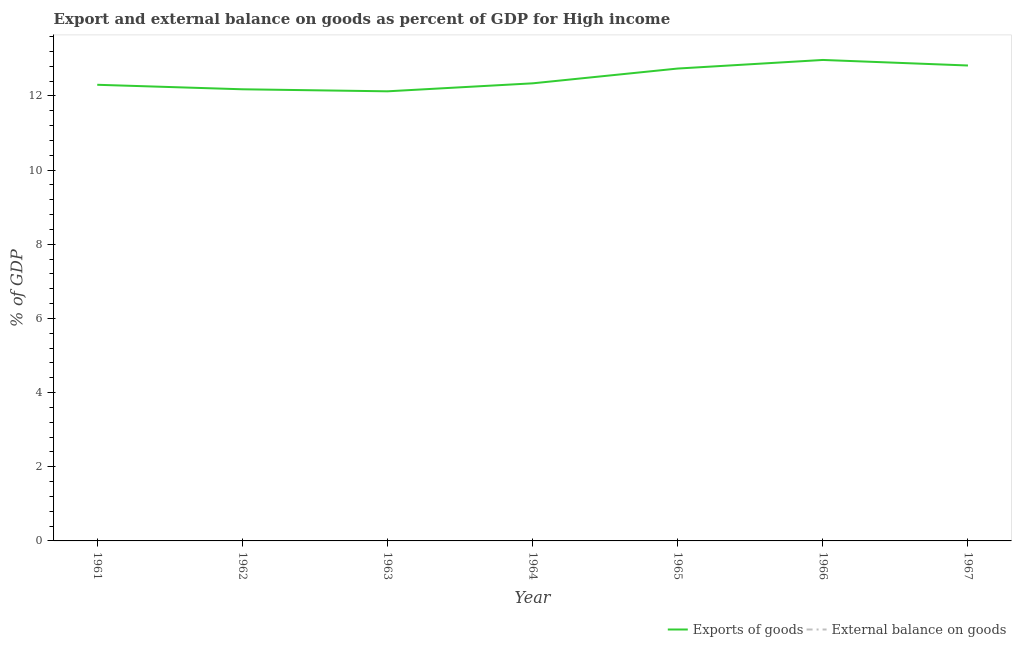How many different coloured lines are there?
Provide a succinct answer. 1. Is the number of lines equal to the number of legend labels?
Your response must be concise. No. Across all years, what is the maximum export of goods as percentage of gdp?
Offer a very short reply. 12.97. Across all years, what is the minimum export of goods as percentage of gdp?
Offer a terse response. 12.13. In which year was the export of goods as percentage of gdp maximum?
Provide a succinct answer. 1966. What is the total external balance on goods as percentage of gdp in the graph?
Ensure brevity in your answer.  0. What is the difference between the export of goods as percentage of gdp in 1963 and that in 1965?
Offer a very short reply. -0.61. What is the difference between the external balance on goods as percentage of gdp in 1964 and the export of goods as percentage of gdp in 1967?
Make the answer very short. -12.82. What is the ratio of the export of goods as percentage of gdp in 1962 to that in 1967?
Your answer should be compact. 0.95. What is the difference between the highest and the second highest export of goods as percentage of gdp?
Provide a succinct answer. 0.15. What is the difference between the highest and the lowest export of goods as percentage of gdp?
Your answer should be compact. 0.85. Is the external balance on goods as percentage of gdp strictly less than the export of goods as percentage of gdp over the years?
Your answer should be very brief. Yes. How many lines are there?
Give a very brief answer. 1. What is the difference between two consecutive major ticks on the Y-axis?
Ensure brevity in your answer.  2. How many legend labels are there?
Ensure brevity in your answer.  2. What is the title of the graph?
Give a very brief answer. Export and external balance on goods as percent of GDP for High income. Does "Commercial service imports" appear as one of the legend labels in the graph?
Offer a very short reply. No. What is the label or title of the Y-axis?
Provide a short and direct response. % of GDP. What is the % of GDP in Exports of goods in 1961?
Offer a terse response. 12.3. What is the % of GDP in Exports of goods in 1962?
Your answer should be very brief. 12.18. What is the % of GDP of Exports of goods in 1963?
Your answer should be compact. 12.13. What is the % of GDP in Exports of goods in 1964?
Offer a terse response. 12.34. What is the % of GDP in External balance on goods in 1964?
Give a very brief answer. 0. What is the % of GDP in Exports of goods in 1965?
Your response must be concise. 12.74. What is the % of GDP of External balance on goods in 1965?
Keep it short and to the point. 0. What is the % of GDP of Exports of goods in 1966?
Your answer should be compact. 12.97. What is the % of GDP of External balance on goods in 1966?
Your answer should be very brief. 0. What is the % of GDP in Exports of goods in 1967?
Offer a very short reply. 12.82. What is the % of GDP of External balance on goods in 1967?
Your answer should be very brief. 0. Across all years, what is the maximum % of GDP in Exports of goods?
Provide a succinct answer. 12.97. Across all years, what is the minimum % of GDP of Exports of goods?
Give a very brief answer. 12.13. What is the total % of GDP of Exports of goods in the graph?
Offer a very short reply. 87.48. What is the total % of GDP of External balance on goods in the graph?
Provide a short and direct response. 0. What is the difference between the % of GDP of Exports of goods in 1961 and that in 1962?
Ensure brevity in your answer.  0.12. What is the difference between the % of GDP in Exports of goods in 1961 and that in 1963?
Keep it short and to the point. 0.18. What is the difference between the % of GDP of Exports of goods in 1961 and that in 1964?
Keep it short and to the point. -0.04. What is the difference between the % of GDP of Exports of goods in 1961 and that in 1965?
Offer a terse response. -0.44. What is the difference between the % of GDP of Exports of goods in 1961 and that in 1966?
Make the answer very short. -0.67. What is the difference between the % of GDP of Exports of goods in 1961 and that in 1967?
Your answer should be compact. -0.52. What is the difference between the % of GDP of Exports of goods in 1962 and that in 1963?
Ensure brevity in your answer.  0.05. What is the difference between the % of GDP of Exports of goods in 1962 and that in 1964?
Ensure brevity in your answer.  -0.16. What is the difference between the % of GDP in Exports of goods in 1962 and that in 1965?
Your answer should be compact. -0.56. What is the difference between the % of GDP of Exports of goods in 1962 and that in 1966?
Provide a short and direct response. -0.79. What is the difference between the % of GDP of Exports of goods in 1962 and that in 1967?
Make the answer very short. -0.64. What is the difference between the % of GDP in Exports of goods in 1963 and that in 1964?
Your answer should be compact. -0.22. What is the difference between the % of GDP of Exports of goods in 1963 and that in 1965?
Provide a short and direct response. -0.61. What is the difference between the % of GDP in Exports of goods in 1963 and that in 1966?
Offer a terse response. -0.85. What is the difference between the % of GDP of Exports of goods in 1963 and that in 1967?
Your answer should be compact. -0.7. What is the difference between the % of GDP of Exports of goods in 1964 and that in 1965?
Give a very brief answer. -0.4. What is the difference between the % of GDP of Exports of goods in 1964 and that in 1966?
Give a very brief answer. -0.63. What is the difference between the % of GDP in Exports of goods in 1964 and that in 1967?
Give a very brief answer. -0.48. What is the difference between the % of GDP of Exports of goods in 1965 and that in 1966?
Your answer should be compact. -0.23. What is the difference between the % of GDP in Exports of goods in 1965 and that in 1967?
Your answer should be compact. -0.08. What is the difference between the % of GDP of Exports of goods in 1966 and that in 1967?
Keep it short and to the point. 0.15. What is the average % of GDP in Exports of goods per year?
Offer a terse response. 12.5. What is the ratio of the % of GDP in Exports of goods in 1961 to that in 1963?
Keep it short and to the point. 1.01. What is the ratio of the % of GDP in Exports of goods in 1961 to that in 1965?
Your answer should be very brief. 0.97. What is the ratio of the % of GDP in Exports of goods in 1961 to that in 1966?
Your answer should be compact. 0.95. What is the ratio of the % of GDP in Exports of goods in 1961 to that in 1967?
Offer a terse response. 0.96. What is the ratio of the % of GDP in Exports of goods in 1962 to that in 1964?
Provide a succinct answer. 0.99. What is the ratio of the % of GDP of Exports of goods in 1962 to that in 1965?
Ensure brevity in your answer.  0.96. What is the ratio of the % of GDP in Exports of goods in 1962 to that in 1966?
Offer a terse response. 0.94. What is the ratio of the % of GDP in Exports of goods in 1962 to that in 1967?
Make the answer very short. 0.95. What is the ratio of the % of GDP of Exports of goods in 1963 to that in 1964?
Your answer should be compact. 0.98. What is the ratio of the % of GDP of Exports of goods in 1963 to that in 1965?
Ensure brevity in your answer.  0.95. What is the ratio of the % of GDP of Exports of goods in 1963 to that in 1966?
Provide a succinct answer. 0.93. What is the ratio of the % of GDP of Exports of goods in 1963 to that in 1967?
Offer a terse response. 0.95. What is the ratio of the % of GDP of Exports of goods in 1964 to that in 1965?
Keep it short and to the point. 0.97. What is the ratio of the % of GDP of Exports of goods in 1964 to that in 1966?
Your response must be concise. 0.95. What is the ratio of the % of GDP of Exports of goods in 1964 to that in 1967?
Your response must be concise. 0.96. What is the ratio of the % of GDP in Exports of goods in 1965 to that in 1966?
Offer a terse response. 0.98. What is the ratio of the % of GDP in Exports of goods in 1965 to that in 1967?
Make the answer very short. 0.99. What is the ratio of the % of GDP of Exports of goods in 1966 to that in 1967?
Make the answer very short. 1.01. What is the difference between the highest and the second highest % of GDP of Exports of goods?
Give a very brief answer. 0.15. What is the difference between the highest and the lowest % of GDP in Exports of goods?
Give a very brief answer. 0.85. 